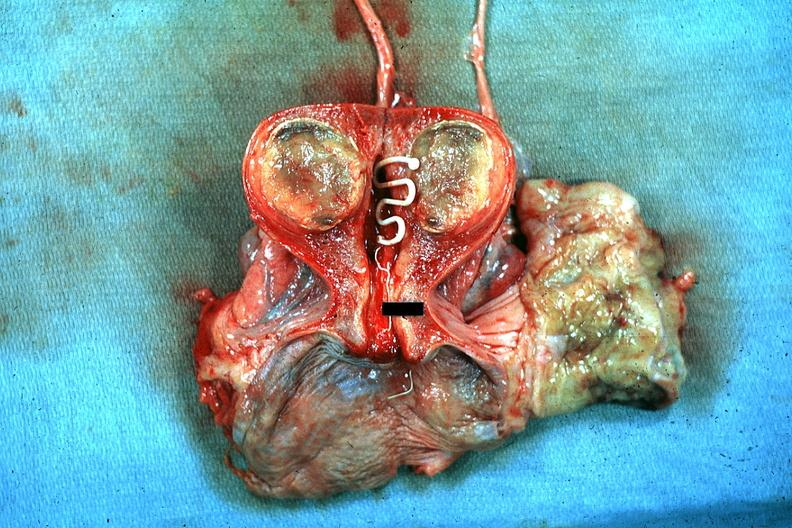what does this image show?
Answer the question using a single word or phrase. Excellent plastic coil with deep red endometrium and degenerating mural myoma 